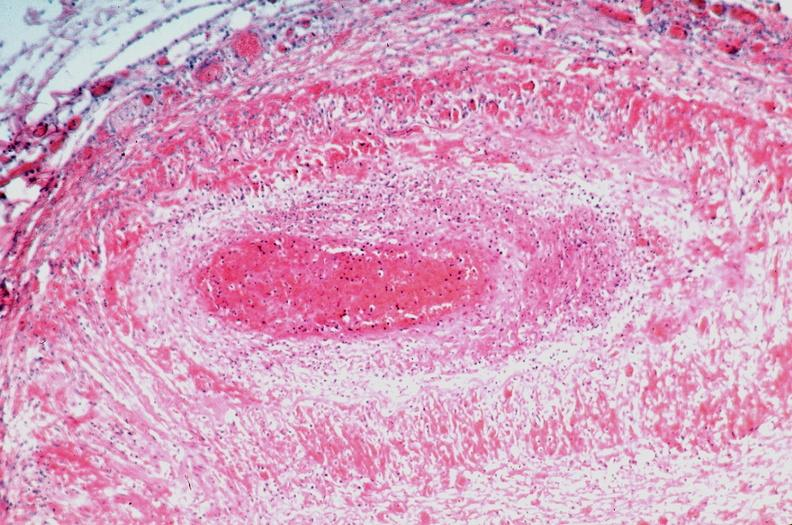s retroperitoneal leiomyosarcoma present?
Answer the question using a single word or phrase. No 